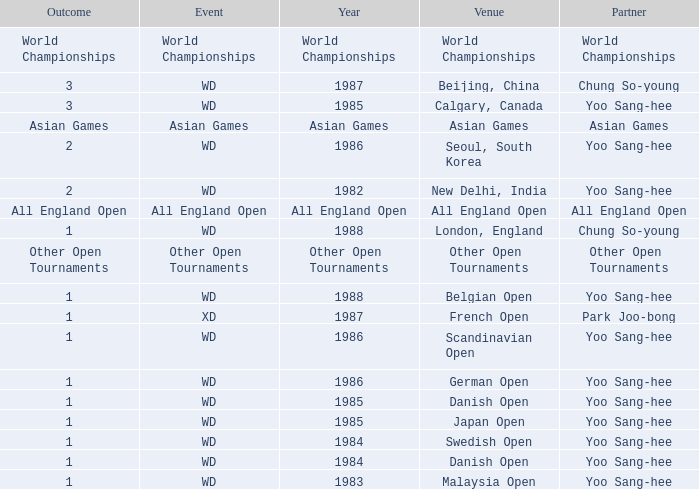What was the Venue in 1986 with an Outcome of 1? Scandinavian Open, German Open. 